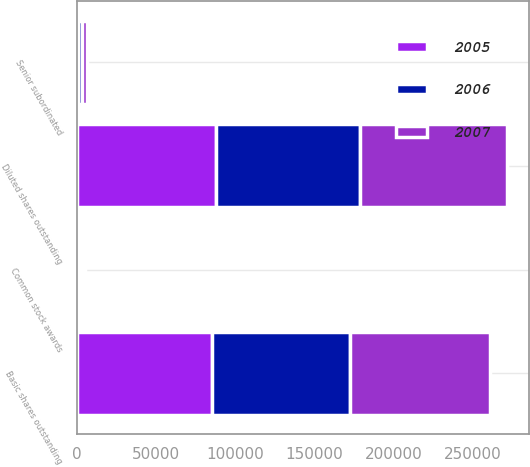Convert chart. <chart><loc_0><loc_0><loc_500><loc_500><stacked_bar_chart><ecel><fcel>Basic shares outstanding<fcel>Common stock awards<fcel>Senior subordinated<fcel>Diluted shares outstanding<nl><fcel>2007<fcel>88390<fcel>1511<fcel>3328<fcel>93229<nl><fcel>2006<fcel>86842<fcel>1823<fcel>2215<fcel>90880<nl><fcel>2005<fcel>85498<fcel>1631<fcel>755<fcel>87884<nl></chart> 